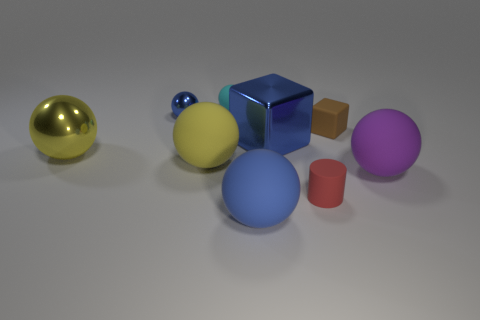Do the brown thing and the blue object that is to the left of the big blue matte ball have the same material?
Provide a succinct answer. No. What is the color of the small rubber ball to the right of the blue metallic thing behind the large blue metallic block?
Keep it short and to the point. Cyan. Is there a rubber sphere that has the same color as the small shiny sphere?
Provide a short and direct response. Yes. There is a rubber ball that is behind the brown object that is to the right of the big sphere that is in front of the small red thing; what size is it?
Give a very brief answer. Small. There is a small cyan thing; is its shape the same as the large matte object that is on the right side of the blue matte thing?
Provide a succinct answer. Yes. What number of other objects are there of the same size as the yellow metal thing?
Provide a succinct answer. 4. There is a cube that is left of the small brown rubber object; how big is it?
Offer a terse response. Large. What number of purple spheres have the same material as the red thing?
Offer a terse response. 1. There is a large shiny thing to the right of the small cyan thing; does it have the same shape as the tiny cyan object?
Offer a very short reply. No. What shape is the tiny thing right of the tiny red matte object?
Make the answer very short. Cube. 